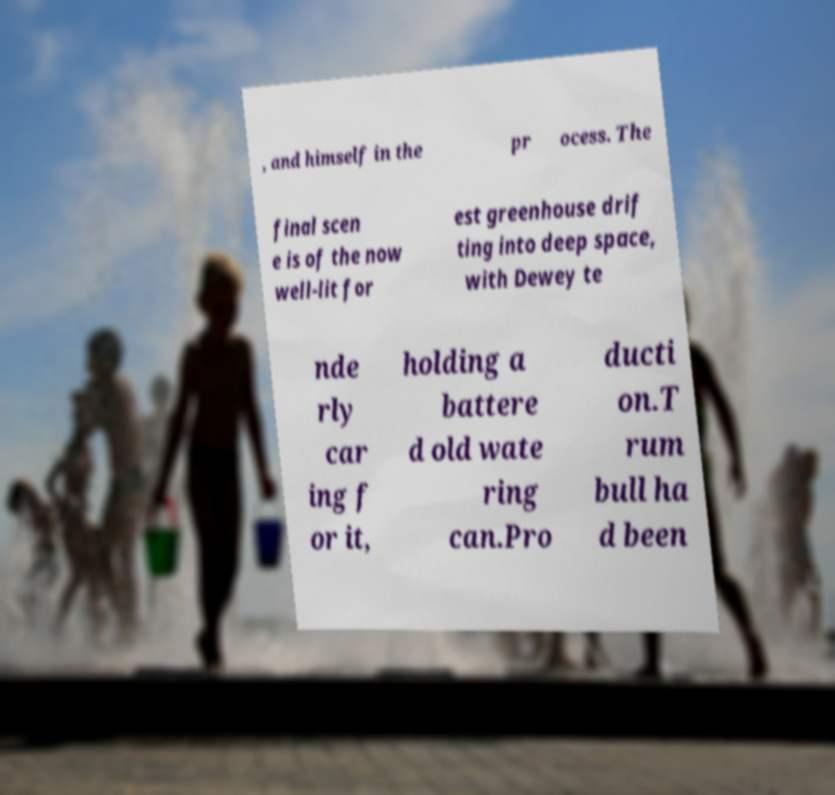Could you assist in decoding the text presented in this image and type it out clearly? , and himself in the pr ocess. The final scen e is of the now well-lit for est greenhouse drif ting into deep space, with Dewey te nde rly car ing f or it, holding a battere d old wate ring can.Pro ducti on.T rum bull ha d been 